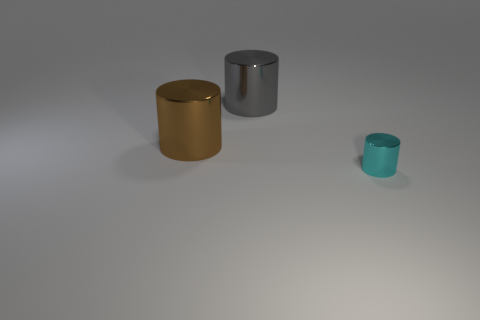What number of big gray things are in front of the cylinder behind the brown shiny object?
Keep it short and to the point. 0. What is the shape of the small object that is made of the same material as the big brown cylinder?
Your answer should be compact. Cylinder. What number of red objects are large metal cylinders or tiny cylinders?
Give a very brief answer. 0. Are there any big gray cylinders that are behind the large cylinder behind the big object that is in front of the large gray object?
Keep it short and to the point. No. Are there fewer big shiny cylinders than small purple matte cubes?
Ensure brevity in your answer.  No. Is the shape of the metal thing that is on the right side of the large gray thing the same as  the gray metallic object?
Keep it short and to the point. Yes. Are there any big gray cylinders?
Ensure brevity in your answer.  Yes. There is a metal cylinder that is on the right side of the large cylinder that is to the right of the big shiny cylinder that is to the left of the gray cylinder; what color is it?
Offer a very short reply. Cyan. Is the number of big gray cylinders that are to the left of the large gray cylinder the same as the number of shiny objects that are in front of the tiny thing?
Your response must be concise. Yes. There is a brown thing that is the same size as the gray object; what is its shape?
Offer a terse response. Cylinder. 